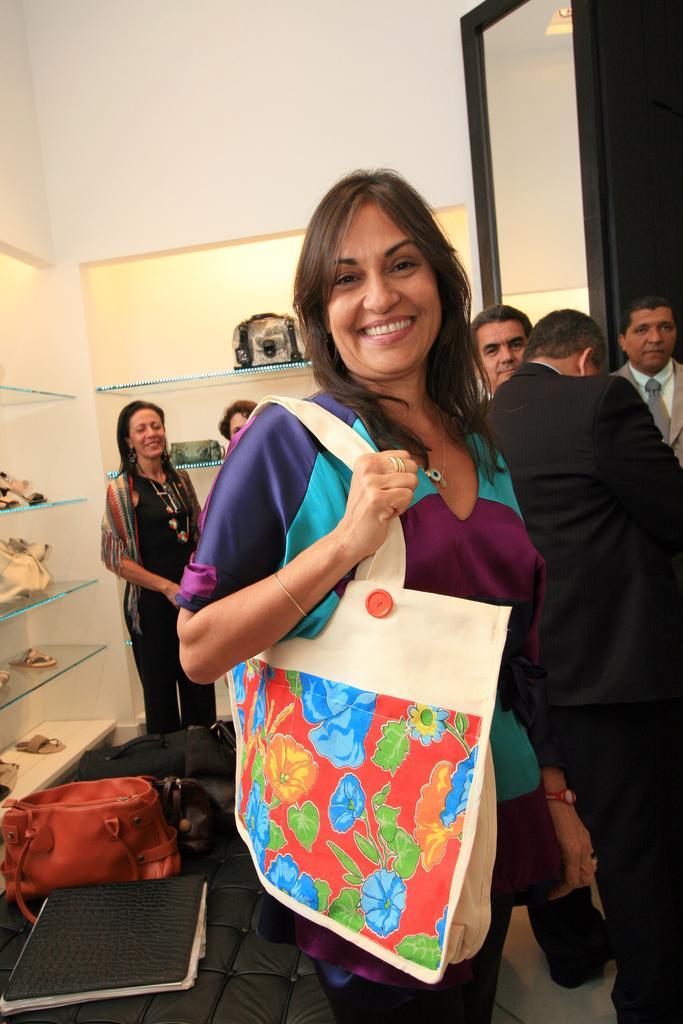Could you give a brief overview of what you see in this image? This is an image clicked inside the room. In the middle of the image there is a woman standing, wearing a bag to her right hand and smiling. In the background I can see some people are standing. In the background there is a wall. On the right side of the image there is a rack and some things are placed In that rack. On the left bottom of the image I can see two bags and one file. 